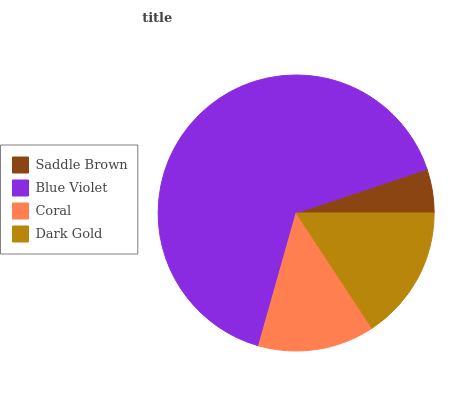Is Saddle Brown the minimum?
Answer yes or no. Yes. Is Blue Violet the maximum?
Answer yes or no. Yes. Is Coral the minimum?
Answer yes or no. No. Is Coral the maximum?
Answer yes or no. No. Is Blue Violet greater than Coral?
Answer yes or no. Yes. Is Coral less than Blue Violet?
Answer yes or no. Yes. Is Coral greater than Blue Violet?
Answer yes or no. No. Is Blue Violet less than Coral?
Answer yes or no. No. Is Dark Gold the high median?
Answer yes or no. Yes. Is Coral the low median?
Answer yes or no. Yes. Is Blue Violet the high median?
Answer yes or no. No. Is Saddle Brown the low median?
Answer yes or no. No. 